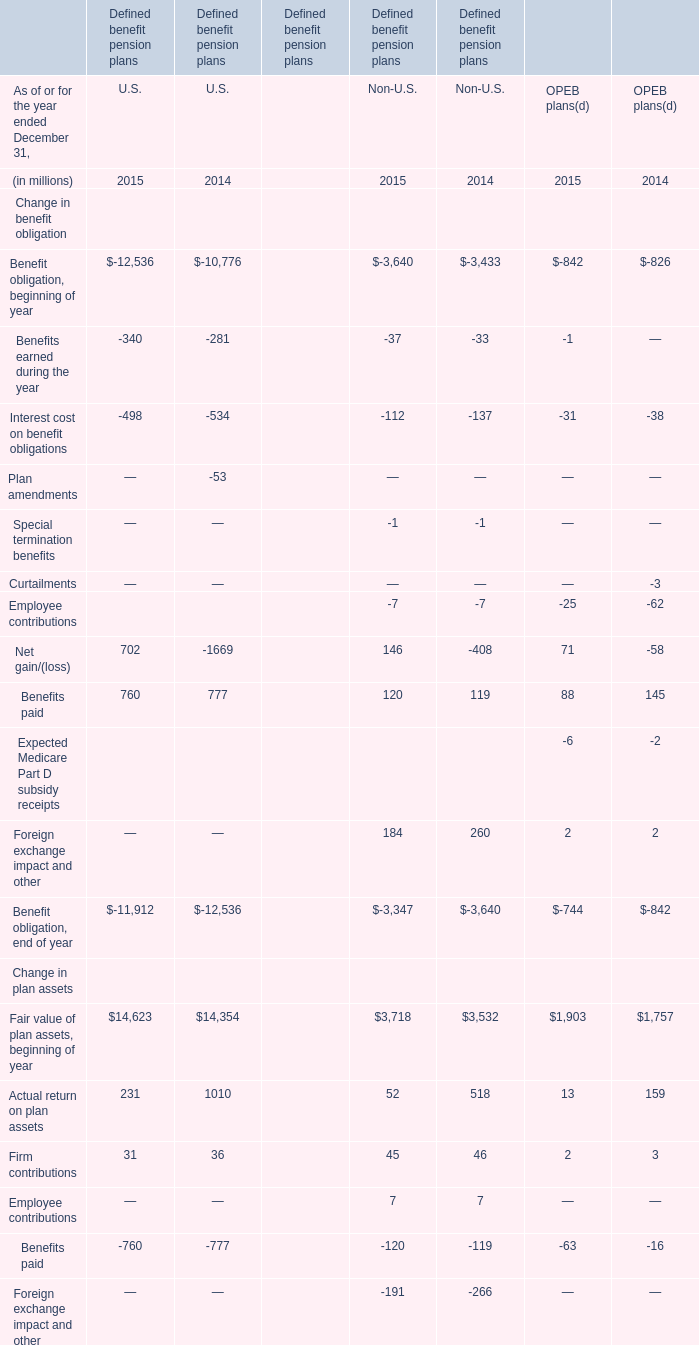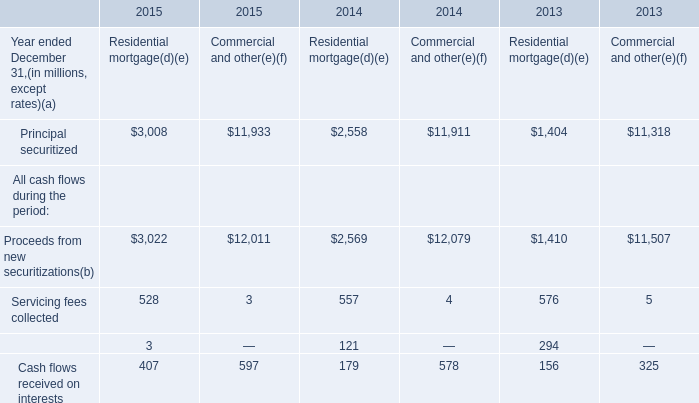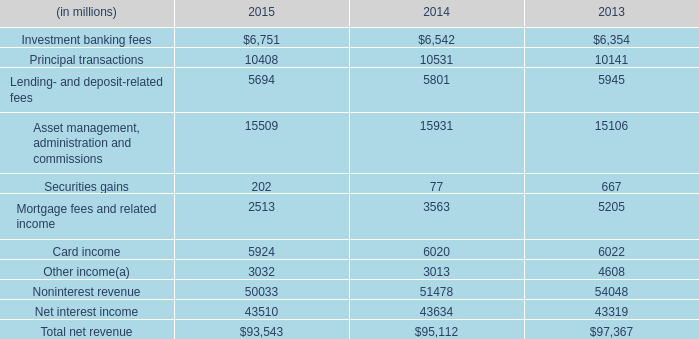What's the current growth rate of Actual return on plan assets in terms of OPEB plans? 
Computations: ((13 - 159) / 159)
Answer: -0.91824. 